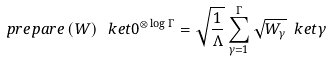Convert formula to latex. <formula><loc_0><loc_0><loc_500><loc_500>p r e p a r e \left ( W \right ) \ k e t { 0 } ^ { \otimes \log \Gamma } = \sqrt { \frac { 1 } { \Lambda } } \sum _ { \gamma = 1 } ^ { \Gamma } \sqrt { W _ { \gamma } } \ k e t { \gamma }</formula> 